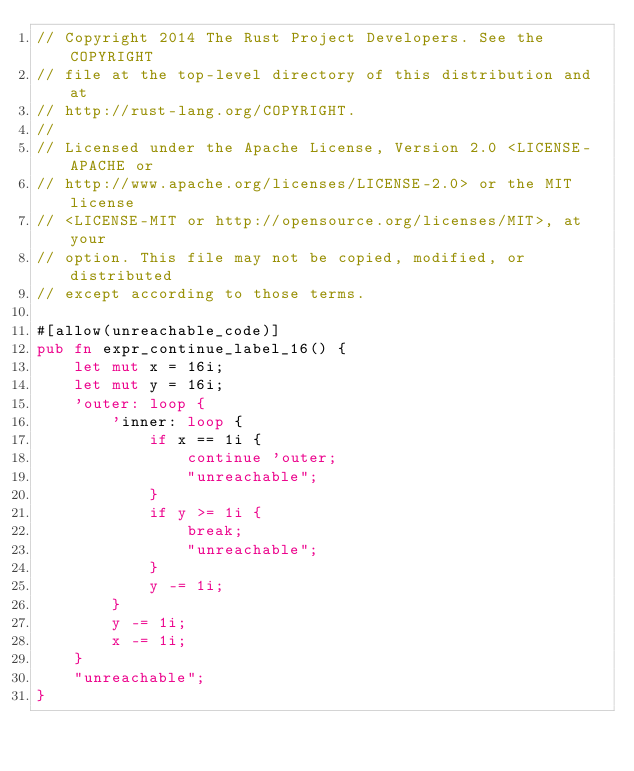Convert code to text. <code><loc_0><loc_0><loc_500><loc_500><_Rust_>// Copyright 2014 The Rust Project Developers. See the COPYRIGHT
// file at the top-level directory of this distribution and at
// http://rust-lang.org/COPYRIGHT.
//
// Licensed under the Apache License, Version 2.0 <LICENSE-APACHE or
// http://www.apache.org/licenses/LICENSE-2.0> or the MIT license
// <LICENSE-MIT or http://opensource.org/licenses/MIT>, at your
// option. This file may not be copied, modified, or distributed
// except according to those terms.

#[allow(unreachable_code)]
pub fn expr_continue_label_16() {
    let mut x = 16i;
    let mut y = 16i;
    'outer: loop {
        'inner: loop {
            if x == 1i {
                continue 'outer;
                "unreachable";
            }
            if y >= 1i {
                break;
                "unreachable";
            }
            y -= 1i;
        }
        y -= 1i;
        x -= 1i;
    }
    "unreachable";
}
</code> 